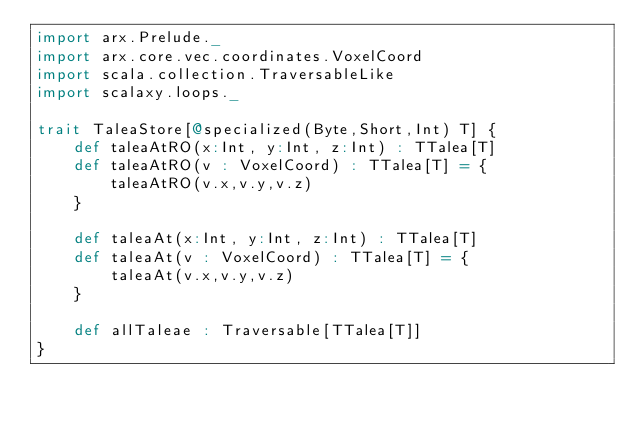Convert code to text. <code><loc_0><loc_0><loc_500><loc_500><_Scala_>import arx.Prelude._
import arx.core.vec.coordinates.VoxelCoord
import scala.collection.TraversableLike
import scalaxy.loops._

trait TaleaStore[@specialized(Byte,Short,Int) T] {
	def taleaAtRO(x:Int, y:Int, z:Int) : TTalea[T]
	def taleaAtRO(v : VoxelCoord) : TTalea[T] = {
		taleaAtRO(v.x,v.y,v.z)
	}

	def taleaAt(x:Int, y:Int, z:Int) : TTalea[T]
	def taleaAt(v : VoxelCoord) : TTalea[T] = {
		taleaAt(v.x,v.y,v.z)
	}

	def allTaleae : Traversable[TTalea[T]]
}
</code> 